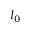<formula> <loc_0><loc_0><loc_500><loc_500>l _ { 0 }</formula> 